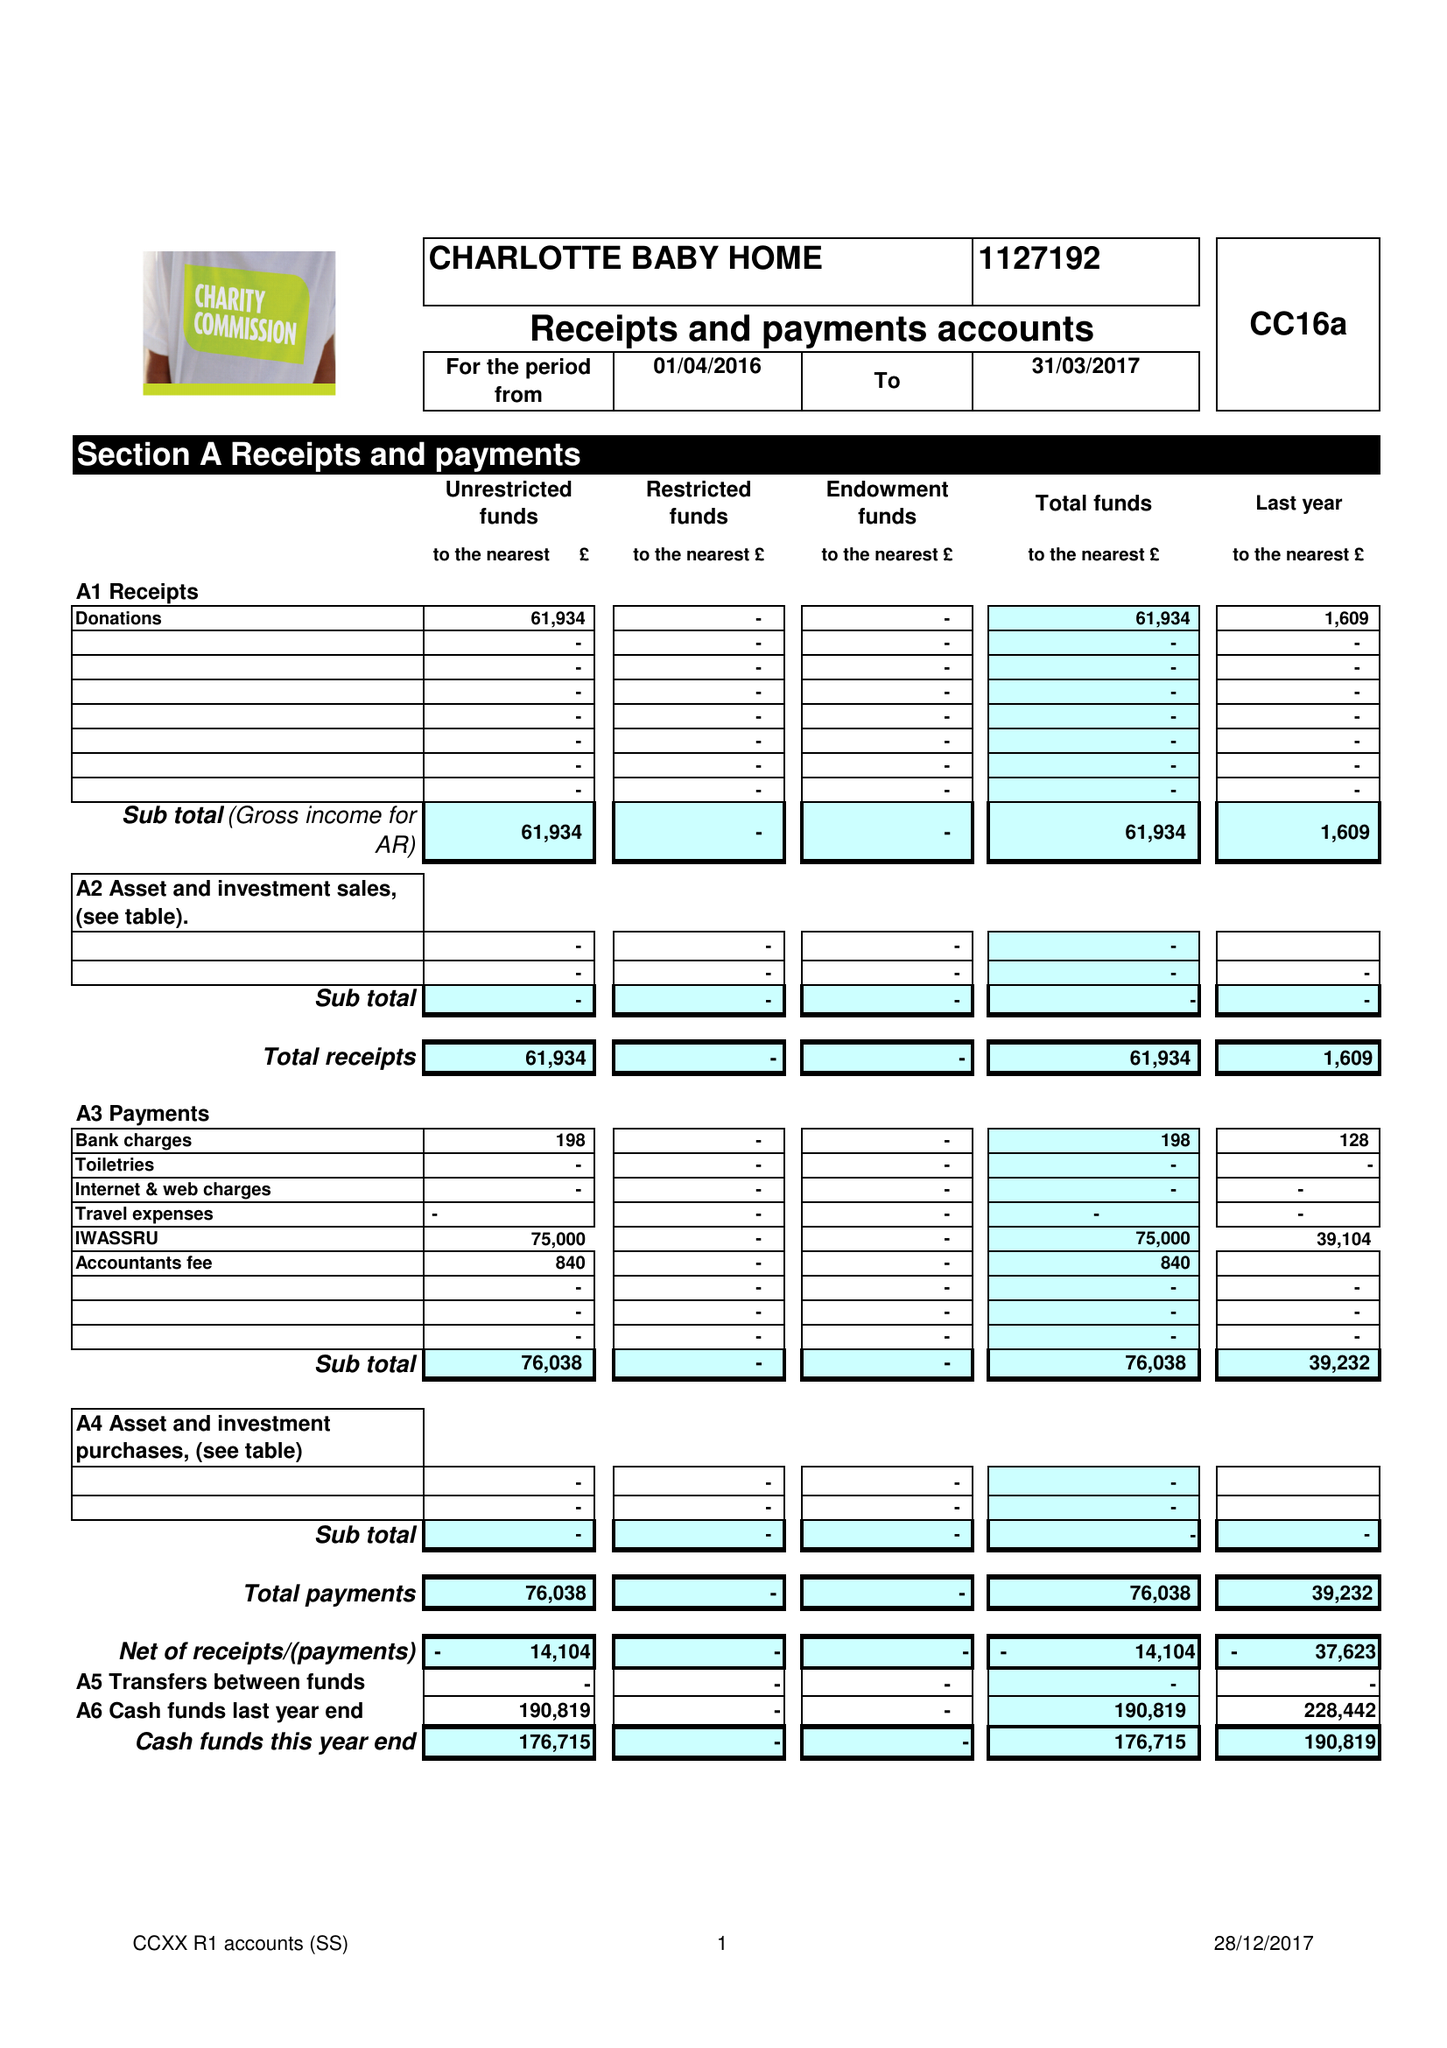What is the value for the address__post_town?
Answer the question using a single word or phrase. LONDON 